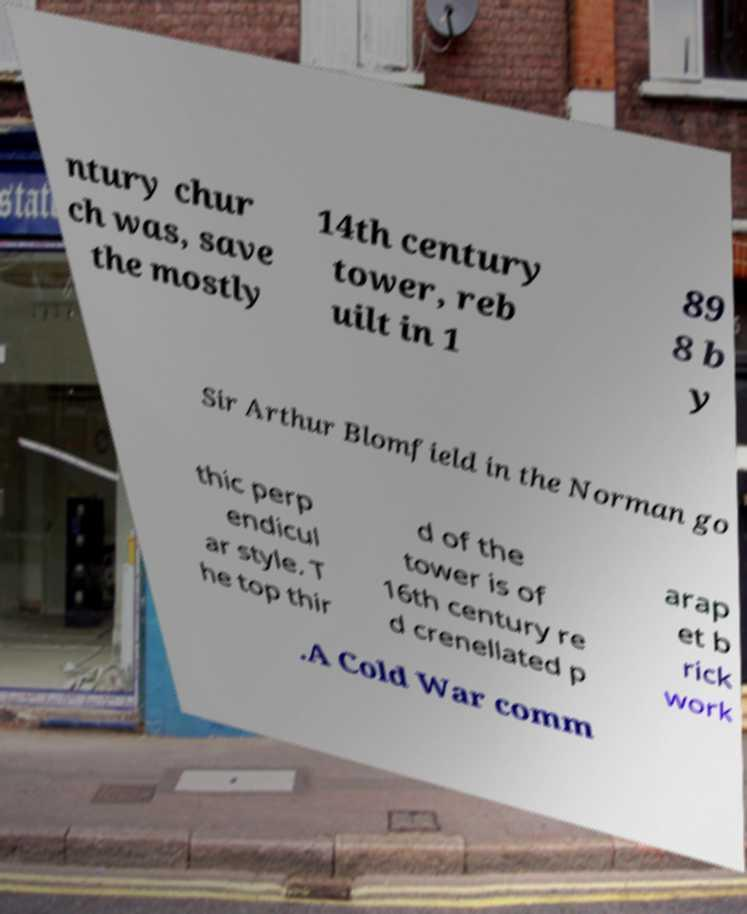Please read and relay the text visible in this image. What does it say? ntury chur ch was, save the mostly 14th century tower, reb uilt in 1 89 8 b y Sir Arthur Blomfield in the Norman go thic perp endicul ar style. T he top thir d of the tower is of 16th century re d crenellated p arap et b rick work .A Cold War comm 